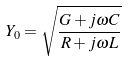<formula> <loc_0><loc_0><loc_500><loc_500>Y _ { 0 } = \sqrt { \frac { G + j \omega C } { R + j \omega L } }</formula> 